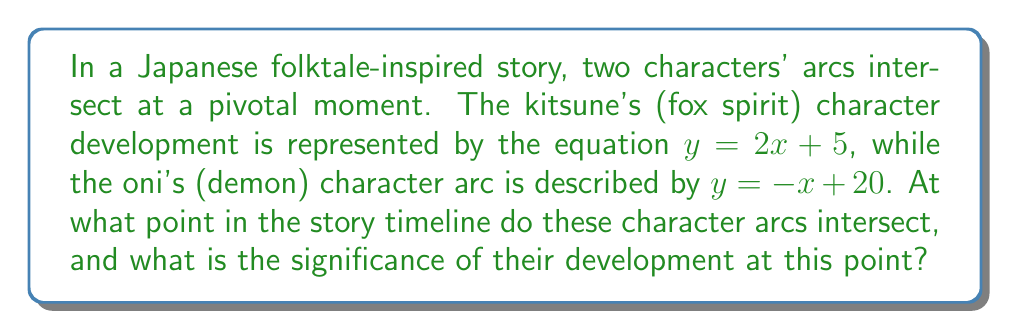Help me with this question. To find the intersection point of the two character arcs, we need to solve the system of linear equations:

$$\begin{cases}
y = 2x + 5 \quad \text{(kitsune's arc)} \\
y = -x + 20 \quad \text{(oni's arc)}
\end{cases}$$

1) Since both equations are equal to y, we can set them equal to each other:

   $2x + 5 = -x + 20$

2) Add $x$ to both sides:

   $3x + 5 = 20$

3) Subtract 5 from both sides:

   $3x = 15$

4) Divide both sides by 3:

   $x = 5$

5) Now that we know $x$, we can substitute it into either of the original equations to find $y$. Let's use the kitsune's equation:

   $y = 2(5) + 5 = 10 + 5 = 15$

Therefore, the intersection point is $(5, 15)$.

In the context of the story, this means the character arcs intersect at the point (5, 15) on the story timeline. The x-coordinate (5) represents the point in time when their arcs intersect, while the y-coordinate (15) represents the level of character development at that point.
Answer: $(5, 15)$ 